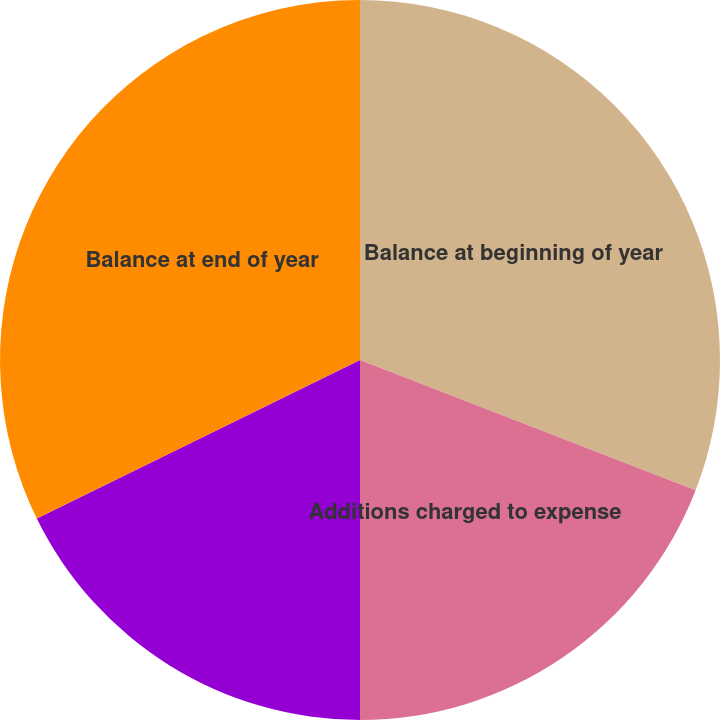Convert chart to OTSL. <chart><loc_0><loc_0><loc_500><loc_500><pie_chart><fcel>Balance at beginning of year<fcel>Additions charged to expense<fcel>Accounts written-off<fcel>Balance at end of year<nl><fcel>30.89%<fcel>19.11%<fcel>17.74%<fcel>32.26%<nl></chart> 